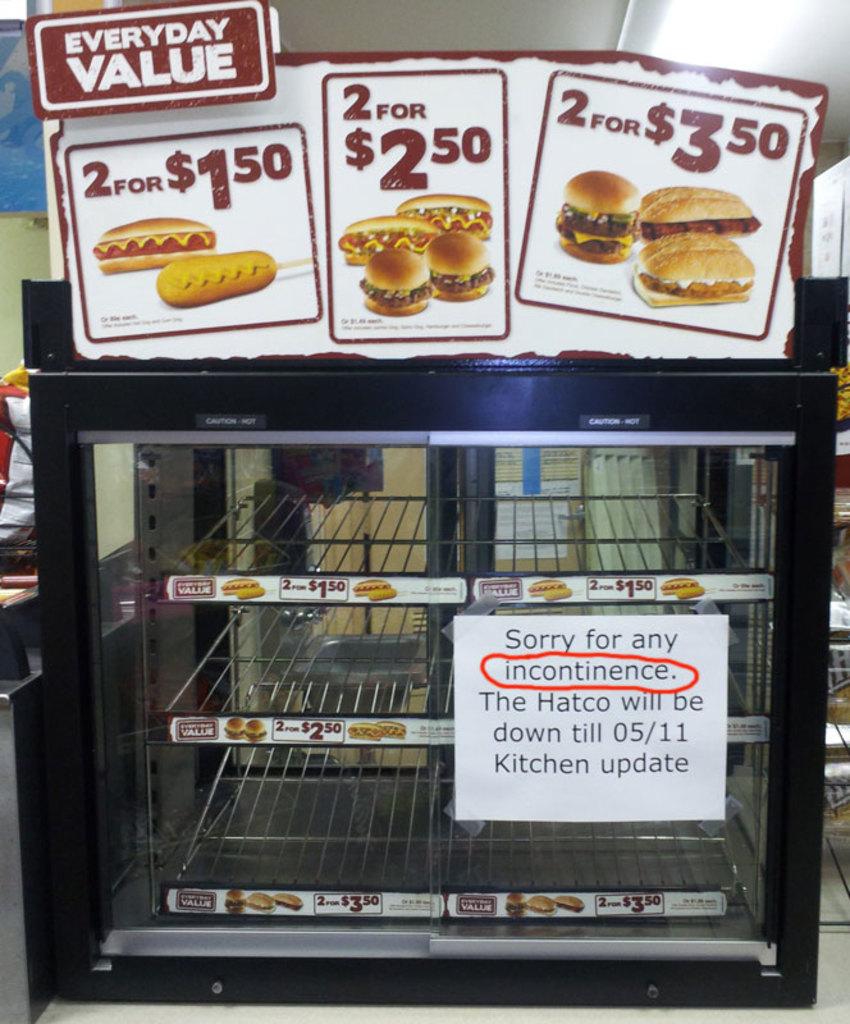When will the hatco be back?
Your answer should be compact. 05/11. 